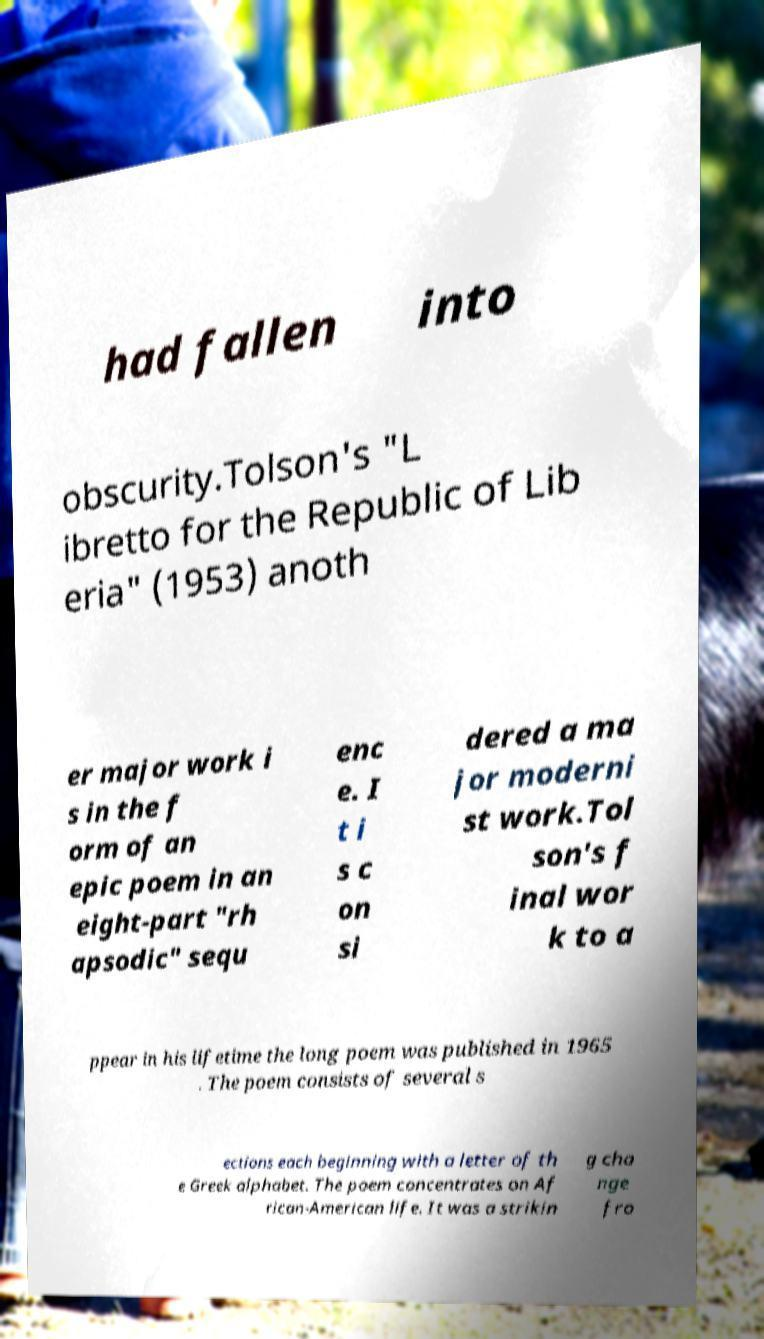I need the written content from this picture converted into text. Can you do that? had fallen into obscurity.Tolson's "L ibretto for the Republic of Lib eria" (1953) anoth er major work i s in the f orm of an epic poem in an eight-part "rh apsodic" sequ enc e. I t i s c on si dered a ma jor moderni st work.Tol son's f inal wor k to a ppear in his lifetime the long poem was published in 1965 . The poem consists of several s ections each beginning with a letter of th e Greek alphabet. The poem concentrates on Af rican-American life. It was a strikin g cha nge fro 